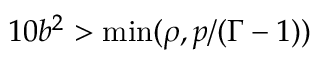<formula> <loc_0><loc_0><loc_500><loc_500>1 0 b ^ { 2 } > \min ( \rho , p / ( \Gamma - 1 ) )</formula> 